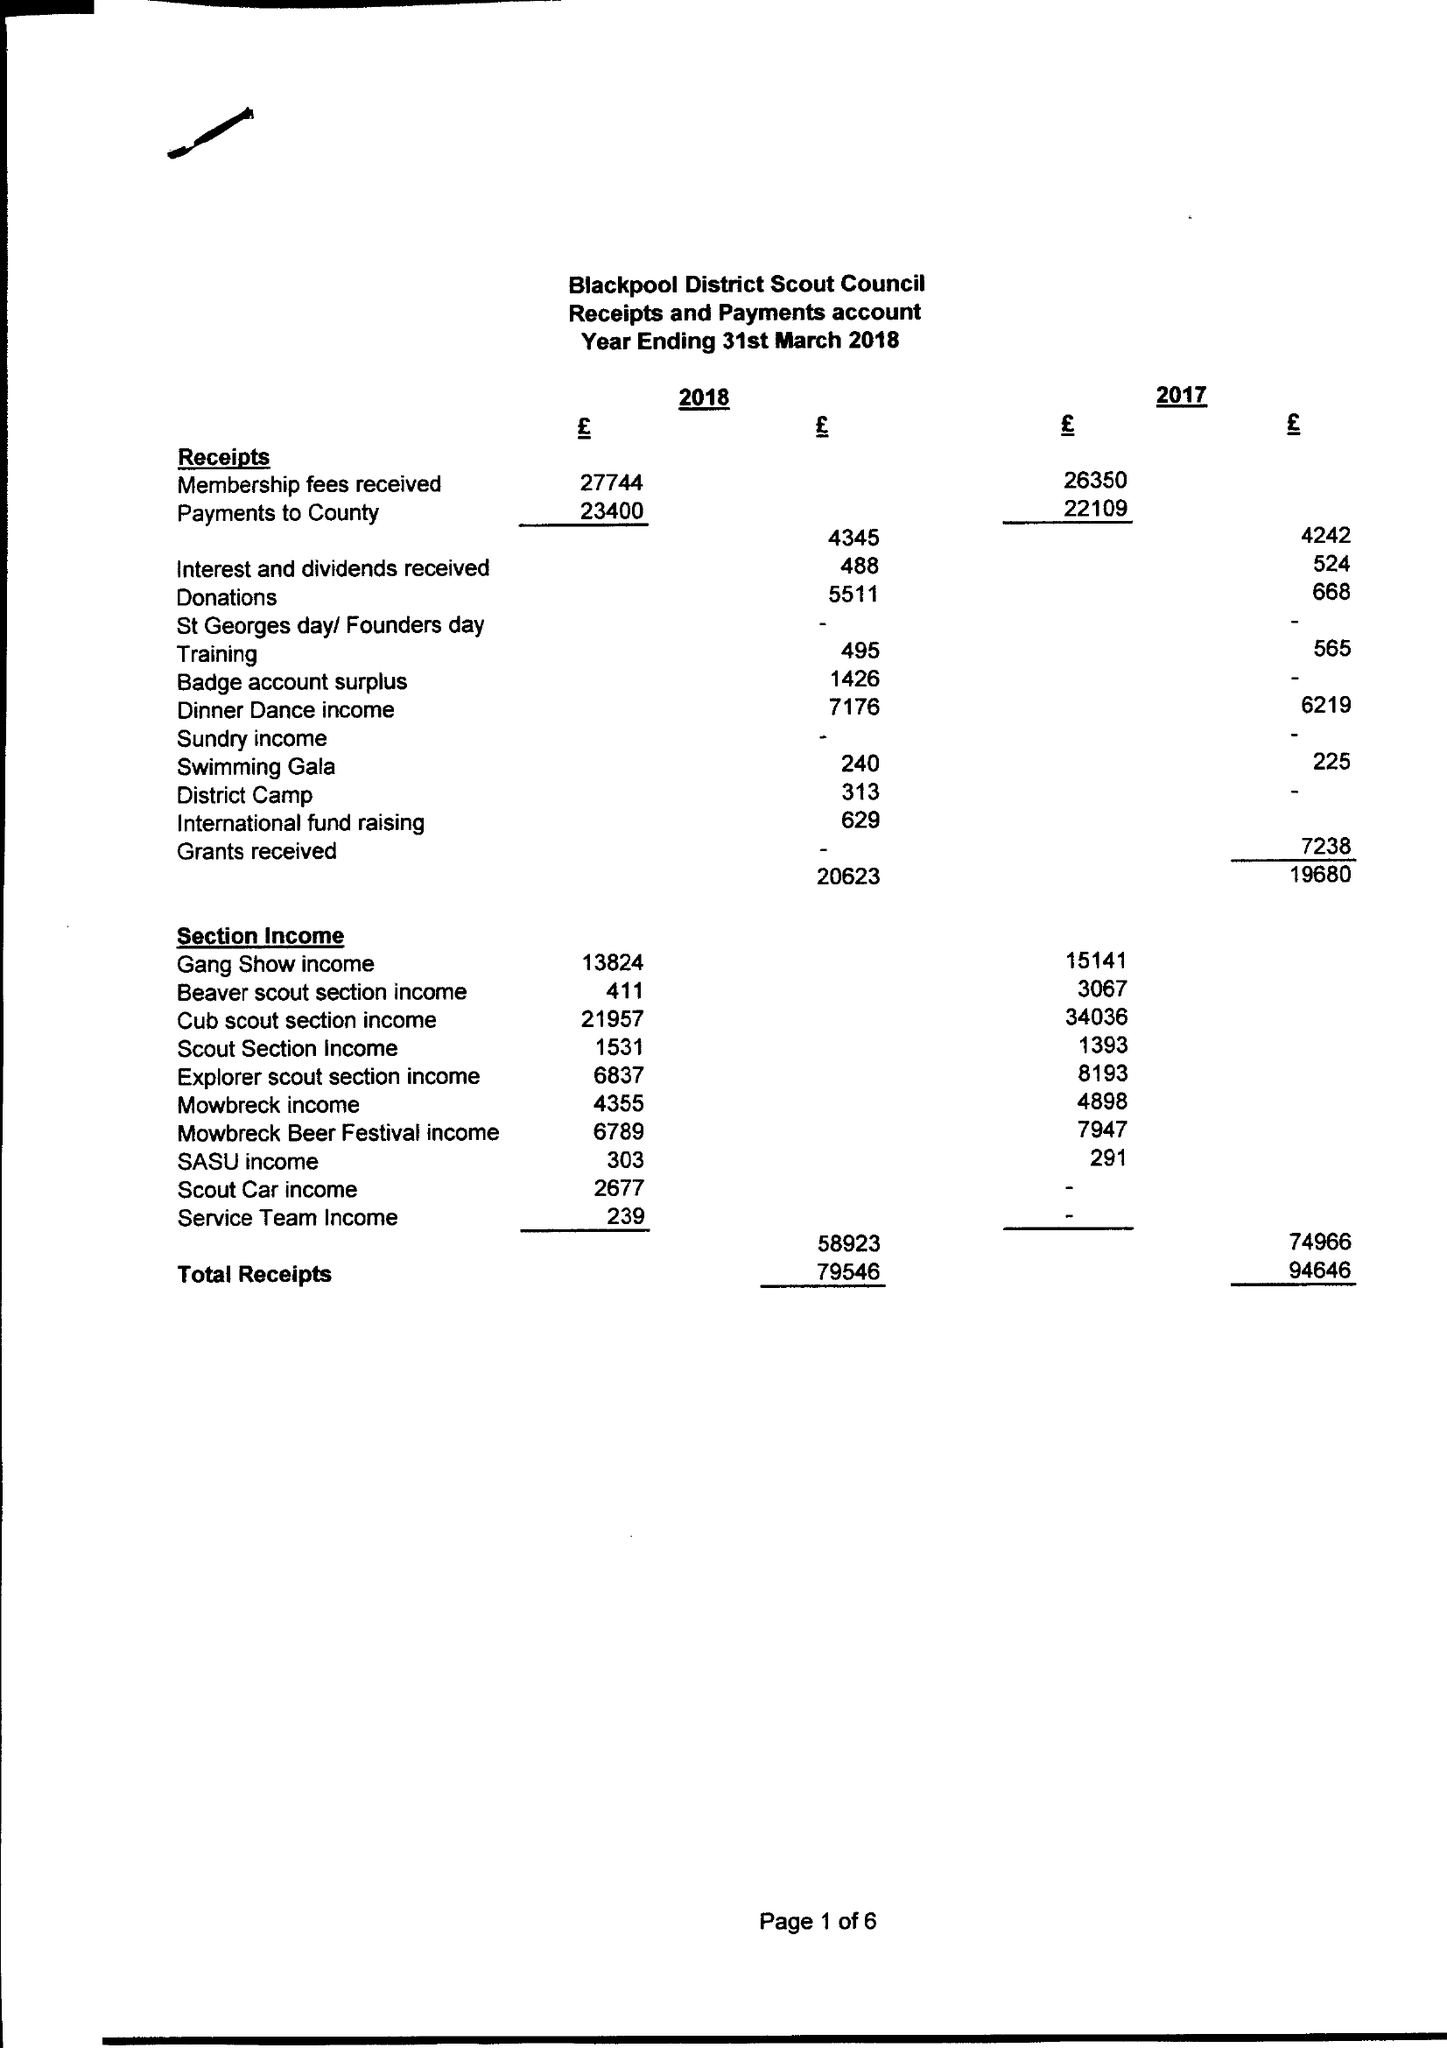What is the value for the charity_name?
Answer the question using a single word or phrase. Blackpool District Scout Council 